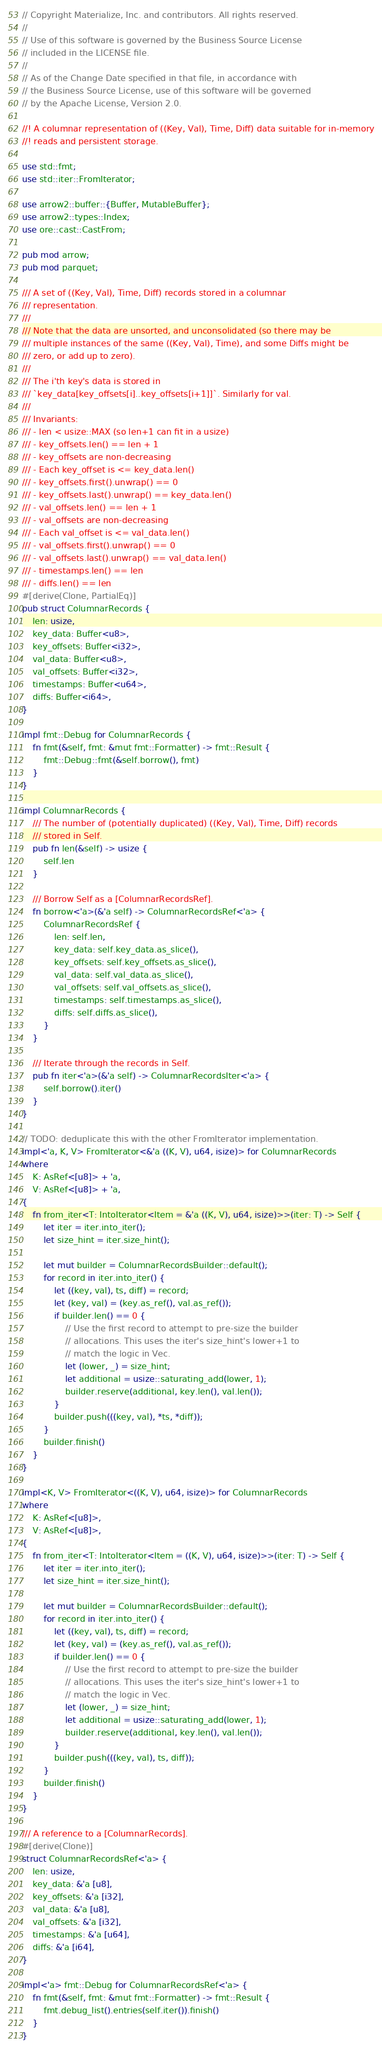<code> <loc_0><loc_0><loc_500><loc_500><_Rust_>// Copyright Materialize, Inc. and contributors. All rights reserved.
//
// Use of this software is governed by the Business Source License
// included in the LICENSE file.
//
// As of the Change Date specified in that file, in accordance with
// the Business Source License, use of this software will be governed
// by the Apache License, Version 2.0.

//! A columnar representation of ((Key, Val), Time, Diff) data suitable for in-memory
//! reads and persistent storage.

use std::fmt;
use std::iter::FromIterator;

use arrow2::buffer::{Buffer, MutableBuffer};
use arrow2::types::Index;
use ore::cast::CastFrom;

pub mod arrow;
pub mod parquet;

/// A set of ((Key, Val), Time, Diff) records stored in a columnar
/// representation.
///
/// Note that the data are unsorted, and unconsolidated (so there may be
/// multiple instances of the same ((Key, Val), Time), and some Diffs might be
/// zero, or add up to zero).
///
/// The i'th key's data is stored in
/// `key_data[key_offsets[i]..key_offsets[i+1]]`. Similarly for val.
///
/// Invariants:
/// - len < usize::MAX (so len+1 can fit in a usize)
/// - key_offsets.len() == len + 1
/// - key_offsets are non-decreasing
/// - Each key_offset is <= key_data.len()
/// - key_offsets.first().unwrap() == 0
/// - key_offsets.last().unwrap() == key_data.len()
/// - val_offsets.len() == len + 1
/// - val_offsets are non-decreasing
/// - Each val_offset is <= val_data.len()
/// - val_offsets.first().unwrap() == 0
/// - val_offsets.last().unwrap() == val_data.len()
/// - timestamps.len() == len
/// - diffs.len() == len
#[derive(Clone, PartialEq)]
pub struct ColumnarRecords {
    len: usize,
    key_data: Buffer<u8>,
    key_offsets: Buffer<i32>,
    val_data: Buffer<u8>,
    val_offsets: Buffer<i32>,
    timestamps: Buffer<u64>,
    diffs: Buffer<i64>,
}

impl fmt::Debug for ColumnarRecords {
    fn fmt(&self, fmt: &mut fmt::Formatter) -> fmt::Result {
        fmt::Debug::fmt(&self.borrow(), fmt)
    }
}

impl ColumnarRecords {
    /// The number of (potentially duplicated) ((Key, Val), Time, Diff) records
    /// stored in Self.
    pub fn len(&self) -> usize {
        self.len
    }

    /// Borrow Self as a [ColumnarRecordsRef].
    fn borrow<'a>(&'a self) -> ColumnarRecordsRef<'a> {
        ColumnarRecordsRef {
            len: self.len,
            key_data: self.key_data.as_slice(),
            key_offsets: self.key_offsets.as_slice(),
            val_data: self.val_data.as_slice(),
            val_offsets: self.val_offsets.as_slice(),
            timestamps: self.timestamps.as_slice(),
            diffs: self.diffs.as_slice(),
        }
    }

    /// Iterate through the records in Self.
    pub fn iter<'a>(&'a self) -> ColumnarRecordsIter<'a> {
        self.borrow().iter()
    }
}

// TODO: deduplicate this with the other FromIterator implementation.
impl<'a, K, V> FromIterator<&'a ((K, V), u64, isize)> for ColumnarRecords
where
    K: AsRef<[u8]> + 'a,
    V: AsRef<[u8]> + 'a,
{
    fn from_iter<T: IntoIterator<Item = &'a ((K, V), u64, isize)>>(iter: T) -> Self {
        let iter = iter.into_iter();
        let size_hint = iter.size_hint();

        let mut builder = ColumnarRecordsBuilder::default();
        for record in iter.into_iter() {
            let ((key, val), ts, diff) = record;
            let (key, val) = (key.as_ref(), val.as_ref());
            if builder.len() == 0 {
                // Use the first record to attempt to pre-size the builder
                // allocations. This uses the iter's size_hint's lower+1 to
                // match the logic in Vec.
                let (lower, _) = size_hint;
                let additional = usize::saturating_add(lower, 1);
                builder.reserve(additional, key.len(), val.len());
            }
            builder.push(((key, val), *ts, *diff));
        }
        builder.finish()
    }
}

impl<K, V> FromIterator<((K, V), u64, isize)> for ColumnarRecords
where
    K: AsRef<[u8]>,
    V: AsRef<[u8]>,
{
    fn from_iter<T: IntoIterator<Item = ((K, V), u64, isize)>>(iter: T) -> Self {
        let iter = iter.into_iter();
        let size_hint = iter.size_hint();

        let mut builder = ColumnarRecordsBuilder::default();
        for record in iter.into_iter() {
            let ((key, val), ts, diff) = record;
            let (key, val) = (key.as_ref(), val.as_ref());
            if builder.len() == 0 {
                // Use the first record to attempt to pre-size the builder
                // allocations. This uses the iter's size_hint's lower+1 to
                // match the logic in Vec.
                let (lower, _) = size_hint;
                let additional = usize::saturating_add(lower, 1);
                builder.reserve(additional, key.len(), val.len());
            }
            builder.push(((key, val), ts, diff));
        }
        builder.finish()
    }
}

/// A reference to a [ColumnarRecords].
#[derive(Clone)]
struct ColumnarRecordsRef<'a> {
    len: usize,
    key_data: &'a [u8],
    key_offsets: &'a [i32],
    val_data: &'a [u8],
    val_offsets: &'a [i32],
    timestamps: &'a [u64],
    diffs: &'a [i64],
}

impl<'a> fmt::Debug for ColumnarRecordsRef<'a> {
    fn fmt(&self, fmt: &mut fmt::Formatter) -> fmt::Result {
        fmt.debug_list().entries(self.iter()).finish()
    }
}
</code> 